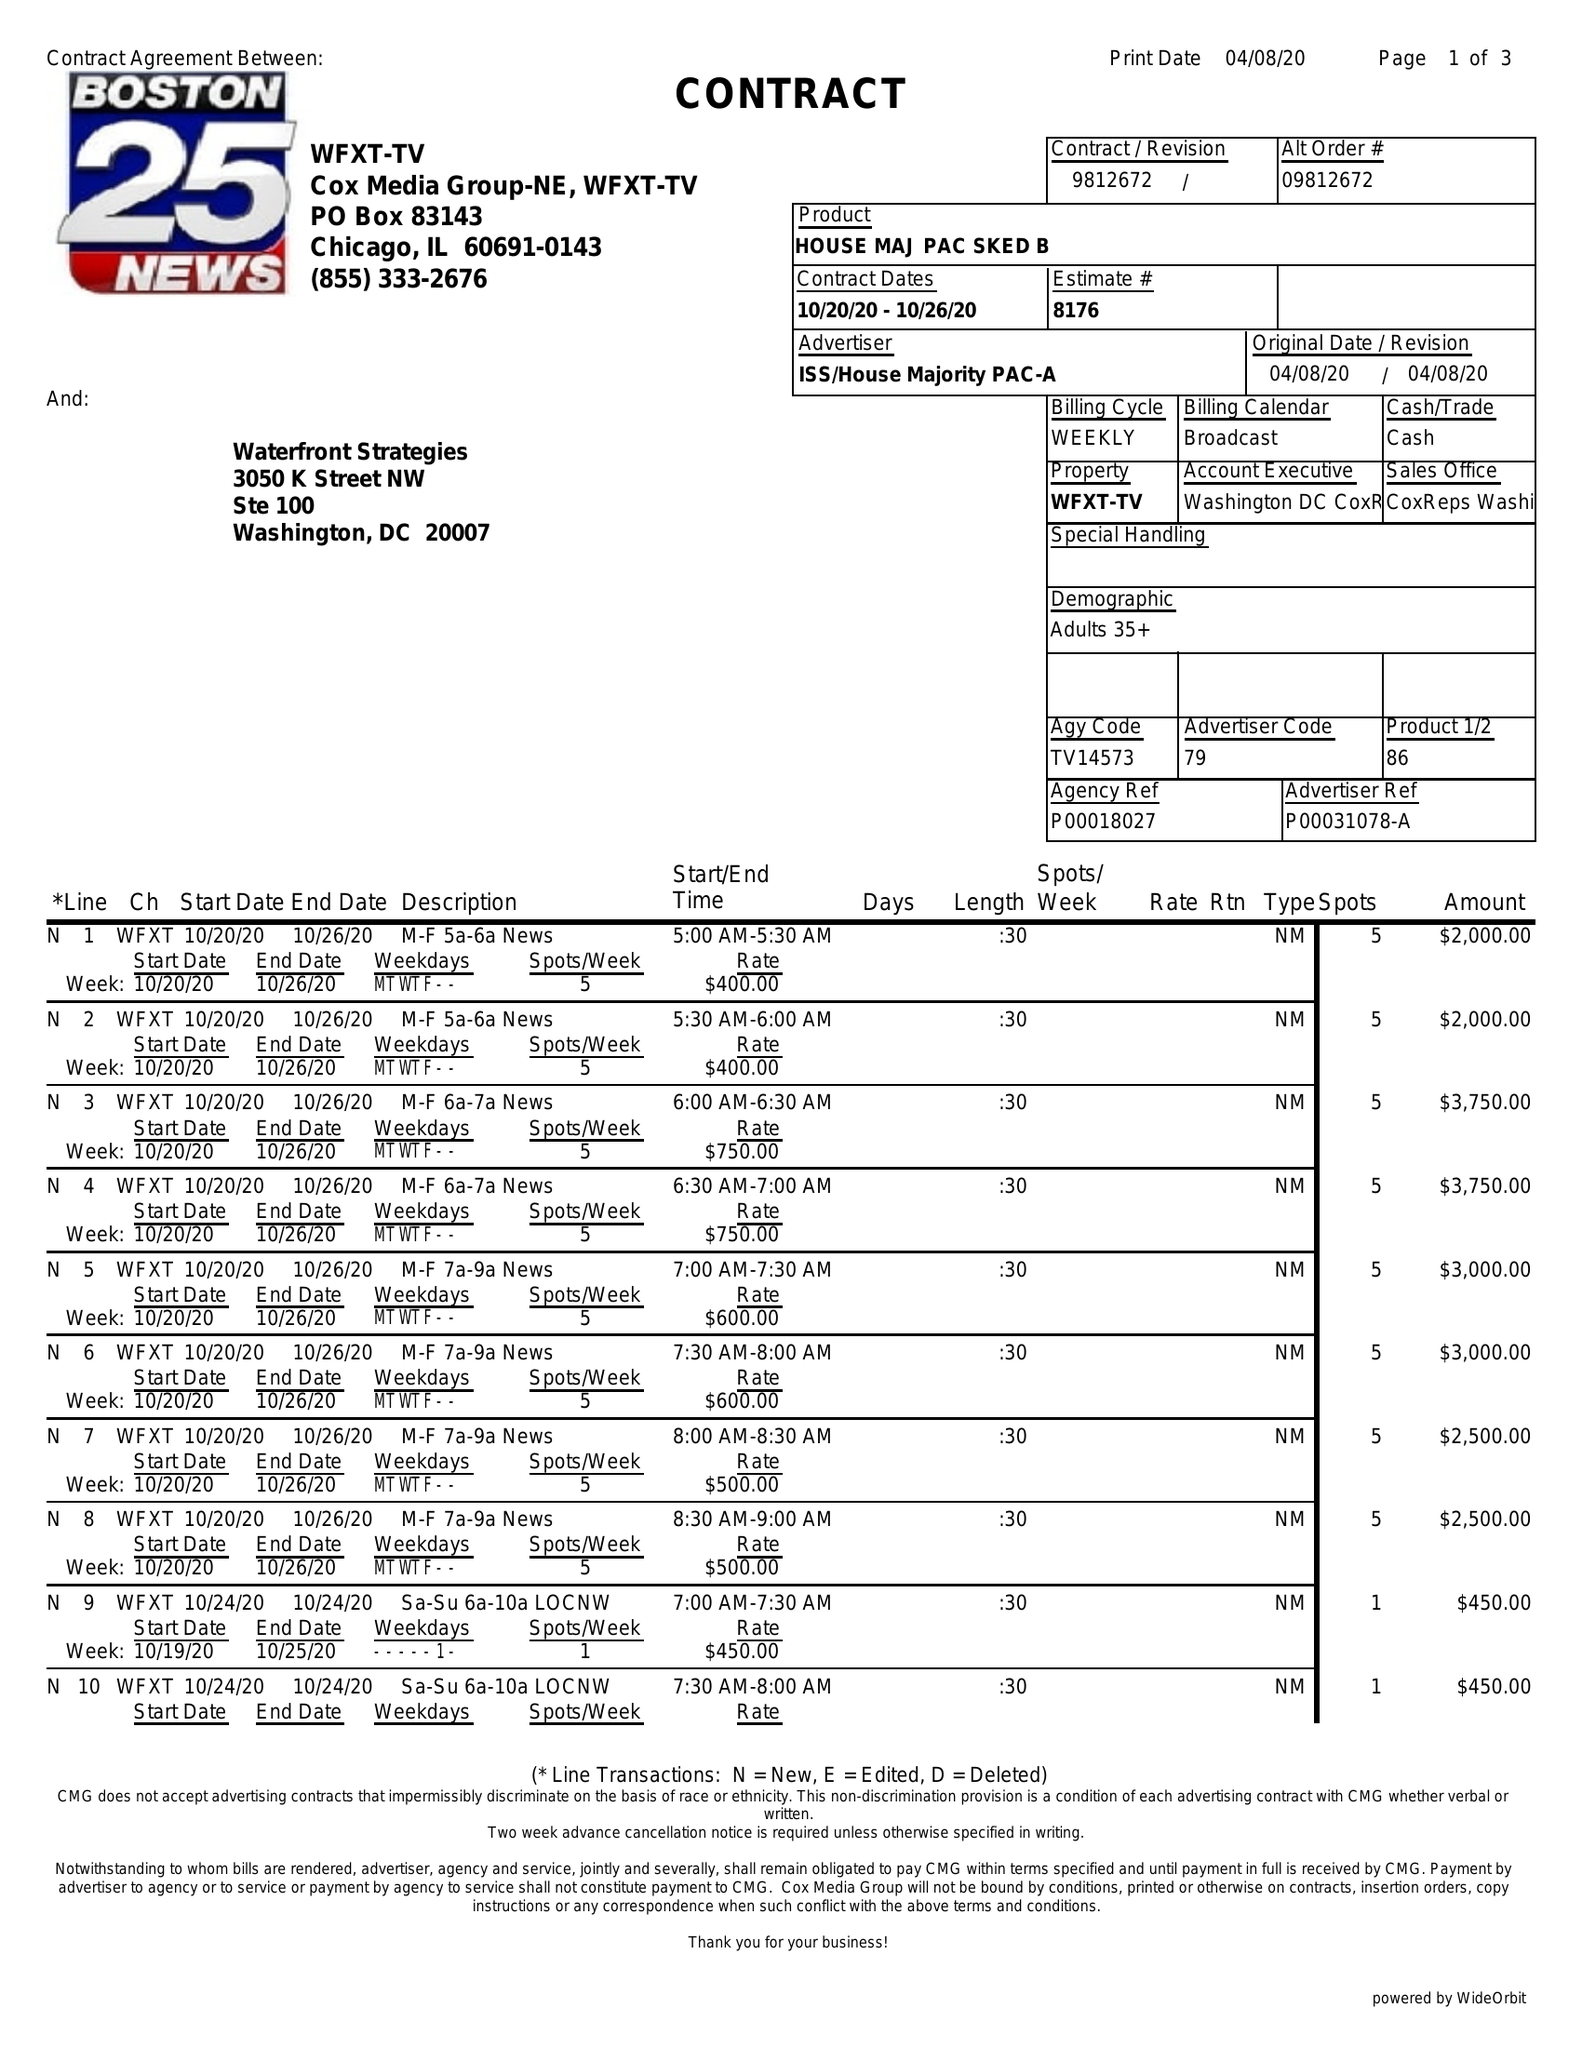What is the value for the flight_to?
Answer the question using a single word or phrase. 10/26/20 